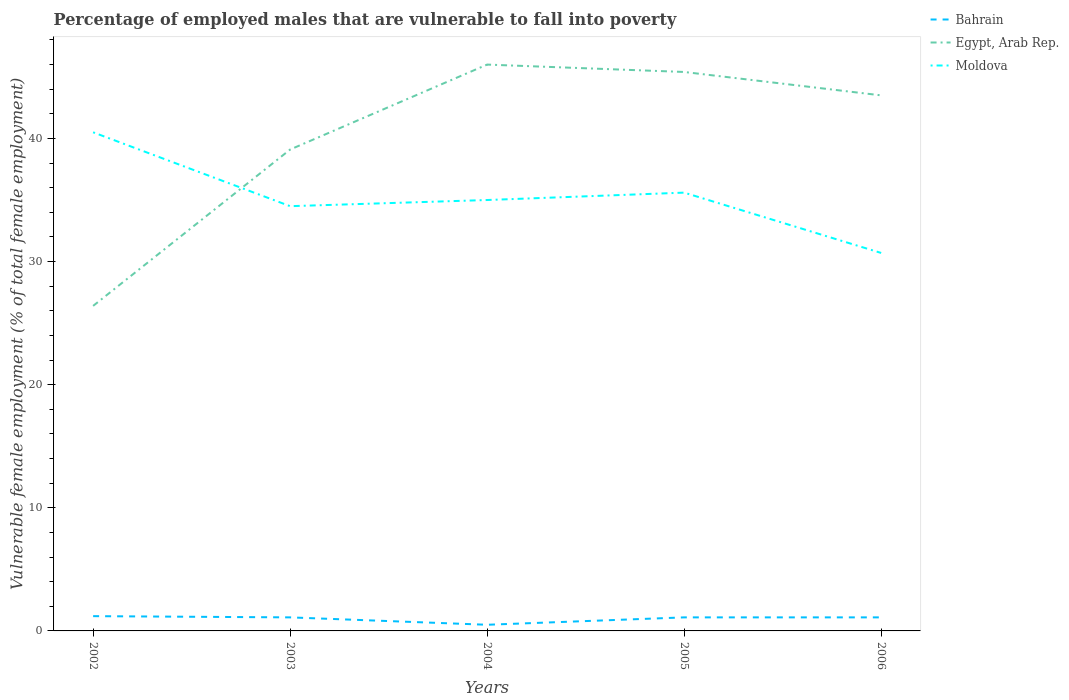How many different coloured lines are there?
Your answer should be compact. 3. Is the number of lines equal to the number of legend labels?
Ensure brevity in your answer.  Yes. Across all years, what is the maximum percentage of employed males who are vulnerable to fall into poverty in Egypt, Arab Rep.?
Offer a terse response. 26.4. What is the total percentage of employed males who are vulnerable to fall into poverty in Egypt, Arab Rep. in the graph?
Make the answer very short. -6.9. What is the difference between the highest and the second highest percentage of employed males who are vulnerable to fall into poverty in Bahrain?
Provide a succinct answer. 0.7. Is the percentage of employed males who are vulnerable to fall into poverty in Egypt, Arab Rep. strictly greater than the percentage of employed males who are vulnerable to fall into poverty in Moldova over the years?
Your answer should be very brief. No. How many lines are there?
Make the answer very short. 3. How many years are there in the graph?
Make the answer very short. 5. What is the difference between two consecutive major ticks on the Y-axis?
Provide a succinct answer. 10. Are the values on the major ticks of Y-axis written in scientific E-notation?
Offer a very short reply. No. Does the graph contain any zero values?
Make the answer very short. No. Does the graph contain grids?
Make the answer very short. No. How many legend labels are there?
Keep it short and to the point. 3. How are the legend labels stacked?
Offer a very short reply. Vertical. What is the title of the graph?
Offer a terse response. Percentage of employed males that are vulnerable to fall into poverty. What is the label or title of the X-axis?
Offer a very short reply. Years. What is the label or title of the Y-axis?
Your answer should be very brief. Vulnerable female employment (% of total female employment). What is the Vulnerable female employment (% of total female employment) of Bahrain in 2002?
Your answer should be very brief. 1.2. What is the Vulnerable female employment (% of total female employment) in Egypt, Arab Rep. in 2002?
Provide a short and direct response. 26.4. What is the Vulnerable female employment (% of total female employment) of Moldova in 2002?
Your answer should be very brief. 40.5. What is the Vulnerable female employment (% of total female employment) in Bahrain in 2003?
Provide a succinct answer. 1.1. What is the Vulnerable female employment (% of total female employment) in Egypt, Arab Rep. in 2003?
Ensure brevity in your answer.  39.1. What is the Vulnerable female employment (% of total female employment) of Moldova in 2003?
Provide a short and direct response. 34.5. What is the Vulnerable female employment (% of total female employment) in Bahrain in 2004?
Provide a short and direct response. 0.5. What is the Vulnerable female employment (% of total female employment) in Bahrain in 2005?
Offer a very short reply. 1.1. What is the Vulnerable female employment (% of total female employment) in Egypt, Arab Rep. in 2005?
Make the answer very short. 45.4. What is the Vulnerable female employment (% of total female employment) of Moldova in 2005?
Ensure brevity in your answer.  35.6. What is the Vulnerable female employment (% of total female employment) of Bahrain in 2006?
Ensure brevity in your answer.  1.1. What is the Vulnerable female employment (% of total female employment) of Egypt, Arab Rep. in 2006?
Your response must be concise. 43.5. What is the Vulnerable female employment (% of total female employment) of Moldova in 2006?
Your response must be concise. 30.7. Across all years, what is the maximum Vulnerable female employment (% of total female employment) of Bahrain?
Provide a succinct answer. 1.2. Across all years, what is the maximum Vulnerable female employment (% of total female employment) in Egypt, Arab Rep.?
Offer a very short reply. 46. Across all years, what is the maximum Vulnerable female employment (% of total female employment) in Moldova?
Make the answer very short. 40.5. Across all years, what is the minimum Vulnerable female employment (% of total female employment) of Bahrain?
Offer a terse response. 0.5. Across all years, what is the minimum Vulnerable female employment (% of total female employment) of Egypt, Arab Rep.?
Your response must be concise. 26.4. Across all years, what is the minimum Vulnerable female employment (% of total female employment) of Moldova?
Your answer should be compact. 30.7. What is the total Vulnerable female employment (% of total female employment) of Bahrain in the graph?
Your answer should be very brief. 5. What is the total Vulnerable female employment (% of total female employment) in Egypt, Arab Rep. in the graph?
Provide a short and direct response. 200.4. What is the total Vulnerable female employment (% of total female employment) of Moldova in the graph?
Your answer should be compact. 176.3. What is the difference between the Vulnerable female employment (% of total female employment) of Egypt, Arab Rep. in 2002 and that in 2004?
Your answer should be very brief. -19.6. What is the difference between the Vulnerable female employment (% of total female employment) in Moldova in 2002 and that in 2004?
Provide a succinct answer. 5.5. What is the difference between the Vulnerable female employment (% of total female employment) of Egypt, Arab Rep. in 2002 and that in 2005?
Keep it short and to the point. -19. What is the difference between the Vulnerable female employment (% of total female employment) of Bahrain in 2002 and that in 2006?
Your answer should be compact. 0.1. What is the difference between the Vulnerable female employment (% of total female employment) in Egypt, Arab Rep. in 2002 and that in 2006?
Your answer should be compact. -17.1. What is the difference between the Vulnerable female employment (% of total female employment) of Moldova in 2002 and that in 2006?
Provide a succinct answer. 9.8. What is the difference between the Vulnerable female employment (% of total female employment) of Bahrain in 2003 and that in 2005?
Your answer should be compact. 0. What is the difference between the Vulnerable female employment (% of total female employment) of Egypt, Arab Rep. in 2003 and that in 2006?
Your response must be concise. -4.4. What is the difference between the Vulnerable female employment (% of total female employment) in Bahrain in 2004 and that in 2005?
Your answer should be very brief. -0.6. What is the difference between the Vulnerable female employment (% of total female employment) in Egypt, Arab Rep. in 2004 and that in 2005?
Offer a terse response. 0.6. What is the difference between the Vulnerable female employment (% of total female employment) in Egypt, Arab Rep. in 2004 and that in 2006?
Give a very brief answer. 2.5. What is the difference between the Vulnerable female employment (% of total female employment) of Egypt, Arab Rep. in 2005 and that in 2006?
Provide a succinct answer. 1.9. What is the difference between the Vulnerable female employment (% of total female employment) in Bahrain in 2002 and the Vulnerable female employment (% of total female employment) in Egypt, Arab Rep. in 2003?
Offer a terse response. -37.9. What is the difference between the Vulnerable female employment (% of total female employment) of Bahrain in 2002 and the Vulnerable female employment (% of total female employment) of Moldova in 2003?
Your answer should be very brief. -33.3. What is the difference between the Vulnerable female employment (% of total female employment) of Bahrain in 2002 and the Vulnerable female employment (% of total female employment) of Egypt, Arab Rep. in 2004?
Make the answer very short. -44.8. What is the difference between the Vulnerable female employment (% of total female employment) in Bahrain in 2002 and the Vulnerable female employment (% of total female employment) in Moldova in 2004?
Provide a short and direct response. -33.8. What is the difference between the Vulnerable female employment (% of total female employment) of Egypt, Arab Rep. in 2002 and the Vulnerable female employment (% of total female employment) of Moldova in 2004?
Ensure brevity in your answer.  -8.6. What is the difference between the Vulnerable female employment (% of total female employment) of Bahrain in 2002 and the Vulnerable female employment (% of total female employment) of Egypt, Arab Rep. in 2005?
Offer a very short reply. -44.2. What is the difference between the Vulnerable female employment (% of total female employment) in Bahrain in 2002 and the Vulnerable female employment (% of total female employment) in Moldova in 2005?
Your answer should be very brief. -34.4. What is the difference between the Vulnerable female employment (% of total female employment) of Egypt, Arab Rep. in 2002 and the Vulnerable female employment (% of total female employment) of Moldova in 2005?
Offer a very short reply. -9.2. What is the difference between the Vulnerable female employment (% of total female employment) of Bahrain in 2002 and the Vulnerable female employment (% of total female employment) of Egypt, Arab Rep. in 2006?
Ensure brevity in your answer.  -42.3. What is the difference between the Vulnerable female employment (% of total female employment) in Bahrain in 2002 and the Vulnerable female employment (% of total female employment) in Moldova in 2006?
Your answer should be compact. -29.5. What is the difference between the Vulnerable female employment (% of total female employment) of Egypt, Arab Rep. in 2002 and the Vulnerable female employment (% of total female employment) of Moldova in 2006?
Keep it short and to the point. -4.3. What is the difference between the Vulnerable female employment (% of total female employment) of Bahrain in 2003 and the Vulnerable female employment (% of total female employment) of Egypt, Arab Rep. in 2004?
Offer a terse response. -44.9. What is the difference between the Vulnerable female employment (% of total female employment) of Bahrain in 2003 and the Vulnerable female employment (% of total female employment) of Moldova in 2004?
Provide a succinct answer. -33.9. What is the difference between the Vulnerable female employment (% of total female employment) in Egypt, Arab Rep. in 2003 and the Vulnerable female employment (% of total female employment) in Moldova in 2004?
Your answer should be very brief. 4.1. What is the difference between the Vulnerable female employment (% of total female employment) of Bahrain in 2003 and the Vulnerable female employment (% of total female employment) of Egypt, Arab Rep. in 2005?
Provide a succinct answer. -44.3. What is the difference between the Vulnerable female employment (% of total female employment) in Bahrain in 2003 and the Vulnerable female employment (% of total female employment) in Moldova in 2005?
Make the answer very short. -34.5. What is the difference between the Vulnerable female employment (% of total female employment) in Bahrain in 2003 and the Vulnerable female employment (% of total female employment) in Egypt, Arab Rep. in 2006?
Ensure brevity in your answer.  -42.4. What is the difference between the Vulnerable female employment (% of total female employment) of Bahrain in 2003 and the Vulnerable female employment (% of total female employment) of Moldova in 2006?
Your response must be concise. -29.6. What is the difference between the Vulnerable female employment (% of total female employment) in Bahrain in 2004 and the Vulnerable female employment (% of total female employment) in Egypt, Arab Rep. in 2005?
Offer a terse response. -44.9. What is the difference between the Vulnerable female employment (% of total female employment) of Bahrain in 2004 and the Vulnerable female employment (% of total female employment) of Moldova in 2005?
Give a very brief answer. -35.1. What is the difference between the Vulnerable female employment (% of total female employment) in Bahrain in 2004 and the Vulnerable female employment (% of total female employment) in Egypt, Arab Rep. in 2006?
Offer a terse response. -43. What is the difference between the Vulnerable female employment (% of total female employment) of Bahrain in 2004 and the Vulnerable female employment (% of total female employment) of Moldova in 2006?
Keep it short and to the point. -30.2. What is the difference between the Vulnerable female employment (% of total female employment) in Egypt, Arab Rep. in 2004 and the Vulnerable female employment (% of total female employment) in Moldova in 2006?
Give a very brief answer. 15.3. What is the difference between the Vulnerable female employment (% of total female employment) of Bahrain in 2005 and the Vulnerable female employment (% of total female employment) of Egypt, Arab Rep. in 2006?
Offer a terse response. -42.4. What is the difference between the Vulnerable female employment (% of total female employment) in Bahrain in 2005 and the Vulnerable female employment (% of total female employment) in Moldova in 2006?
Provide a succinct answer. -29.6. What is the average Vulnerable female employment (% of total female employment) of Egypt, Arab Rep. per year?
Your answer should be compact. 40.08. What is the average Vulnerable female employment (% of total female employment) in Moldova per year?
Your answer should be very brief. 35.26. In the year 2002, what is the difference between the Vulnerable female employment (% of total female employment) of Bahrain and Vulnerable female employment (% of total female employment) of Egypt, Arab Rep.?
Give a very brief answer. -25.2. In the year 2002, what is the difference between the Vulnerable female employment (% of total female employment) in Bahrain and Vulnerable female employment (% of total female employment) in Moldova?
Ensure brevity in your answer.  -39.3. In the year 2002, what is the difference between the Vulnerable female employment (% of total female employment) of Egypt, Arab Rep. and Vulnerable female employment (% of total female employment) of Moldova?
Ensure brevity in your answer.  -14.1. In the year 2003, what is the difference between the Vulnerable female employment (% of total female employment) in Bahrain and Vulnerable female employment (% of total female employment) in Egypt, Arab Rep.?
Your answer should be very brief. -38. In the year 2003, what is the difference between the Vulnerable female employment (% of total female employment) in Bahrain and Vulnerable female employment (% of total female employment) in Moldova?
Provide a succinct answer. -33.4. In the year 2004, what is the difference between the Vulnerable female employment (% of total female employment) of Bahrain and Vulnerable female employment (% of total female employment) of Egypt, Arab Rep.?
Offer a very short reply. -45.5. In the year 2004, what is the difference between the Vulnerable female employment (% of total female employment) in Bahrain and Vulnerable female employment (% of total female employment) in Moldova?
Your answer should be compact. -34.5. In the year 2004, what is the difference between the Vulnerable female employment (% of total female employment) in Egypt, Arab Rep. and Vulnerable female employment (% of total female employment) in Moldova?
Provide a succinct answer. 11. In the year 2005, what is the difference between the Vulnerable female employment (% of total female employment) in Bahrain and Vulnerable female employment (% of total female employment) in Egypt, Arab Rep.?
Your answer should be very brief. -44.3. In the year 2005, what is the difference between the Vulnerable female employment (% of total female employment) of Bahrain and Vulnerable female employment (% of total female employment) of Moldova?
Provide a short and direct response. -34.5. In the year 2005, what is the difference between the Vulnerable female employment (% of total female employment) in Egypt, Arab Rep. and Vulnerable female employment (% of total female employment) in Moldova?
Offer a very short reply. 9.8. In the year 2006, what is the difference between the Vulnerable female employment (% of total female employment) in Bahrain and Vulnerable female employment (% of total female employment) in Egypt, Arab Rep.?
Your answer should be compact. -42.4. In the year 2006, what is the difference between the Vulnerable female employment (% of total female employment) in Bahrain and Vulnerable female employment (% of total female employment) in Moldova?
Give a very brief answer. -29.6. What is the ratio of the Vulnerable female employment (% of total female employment) of Bahrain in 2002 to that in 2003?
Ensure brevity in your answer.  1.09. What is the ratio of the Vulnerable female employment (% of total female employment) in Egypt, Arab Rep. in 2002 to that in 2003?
Keep it short and to the point. 0.68. What is the ratio of the Vulnerable female employment (% of total female employment) of Moldova in 2002 to that in 2003?
Provide a short and direct response. 1.17. What is the ratio of the Vulnerable female employment (% of total female employment) of Bahrain in 2002 to that in 2004?
Keep it short and to the point. 2.4. What is the ratio of the Vulnerable female employment (% of total female employment) in Egypt, Arab Rep. in 2002 to that in 2004?
Make the answer very short. 0.57. What is the ratio of the Vulnerable female employment (% of total female employment) of Moldova in 2002 to that in 2004?
Provide a succinct answer. 1.16. What is the ratio of the Vulnerable female employment (% of total female employment) of Bahrain in 2002 to that in 2005?
Ensure brevity in your answer.  1.09. What is the ratio of the Vulnerable female employment (% of total female employment) in Egypt, Arab Rep. in 2002 to that in 2005?
Make the answer very short. 0.58. What is the ratio of the Vulnerable female employment (% of total female employment) in Moldova in 2002 to that in 2005?
Provide a succinct answer. 1.14. What is the ratio of the Vulnerable female employment (% of total female employment) of Egypt, Arab Rep. in 2002 to that in 2006?
Ensure brevity in your answer.  0.61. What is the ratio of the Vulnerable female employment (% of total female employment) of Moldova in 2002 to that in 2006?
Provide a succinct answer. 1.32. What is the ratio of the Vulnerable female employment (% of total female employment) of Moldova in 2003 to that in 2004?
Provide a short and direct response. 0.99. What is the ratio of the Vulnerable female employment (% of total female employment) of Egypt, Arab Rep. in 2003 to that in 2005?
Your answer should be very brief. 0.86. What is the ratio of the Vulnerable female employment (% of total female employment) of Moldova in 2003 to that in 2005?
Offer a terse response. 0.97. What is the ratio of the Vulnerable female employment (% of total female employment) in Egypt, Arab Rep. in 2003 to that in 2006?
Make the answer very short. 0.9. What is the ratio of the Vulnerable female employment (% of total female employment) in Moldova in 2003 to that in 2006?
Provide a succinct answer. 1.12. What is the ratio of the Vulnerable female employment (% of total female employment) in Bahrain in 2004 to that in 2005?
Make the answer very short. 0.45. What is the ratio of the Vulnerable female employment (% of total female employment) in Egypt, Arab Rep. in 2004 to that in 2005?
Make the answer very short. 1.01. What is the ratio of the Vulnerable female employment (% of total female employment) in Moldova in 2004 to that in 2005?
Offer a very short reply. 0.98. What is the ratio of the Vulnerable female employment (% of total female employment) of Bahrain in 2004 to that in 2006?
Offer a very short reply. 0.45. What is the ratio of the Vulnerable female employment (% of total female employment) in Egypt, Arab Rep. in 2004 to that in 2006?
Keep it short and to the point. 1.06. What is the ratio of the Vulnerable female employment (% of total female employment) in Moldova in 2004 to that in 2006?
Provide a short and direct response. 1.14. What is the ratio of the Vulnerable female employment (% of total female employment) in Egypt, Arab Rep. in 2005 to that in 2006?
Offer a very short reply. 1.04. What is the ratio of the Vulnerable female employment (% of total female employment) in Moldova in 2005 to that in 2006?
Ensure brevity in your answer.  1.16. What is the difference between the highest and the second highest Vulnerable female employment (% of total female employment) of Bahrain?
Provide a succinct answer. 0.1. What is the difference between the highest and the second highest Vulnerable female employment (% of total female employment) of Moldova?
Offer a terse response. 4.9. What is the difference between the highest and the lowest Vulnerable female employment (% of total female employment) of Bahrain?
Make the answer very short. 0.7. What is the difference between the highest and the lowest Vulnerable female employment (% of total female employment) in Egypt, Arab Rep.?
Your response must be concise. 19.6. What is the difference between the highest and the lowest Vulnerable female employment (% of total female employment) in Moldova?
Provide a short and direct response. 9.8. 